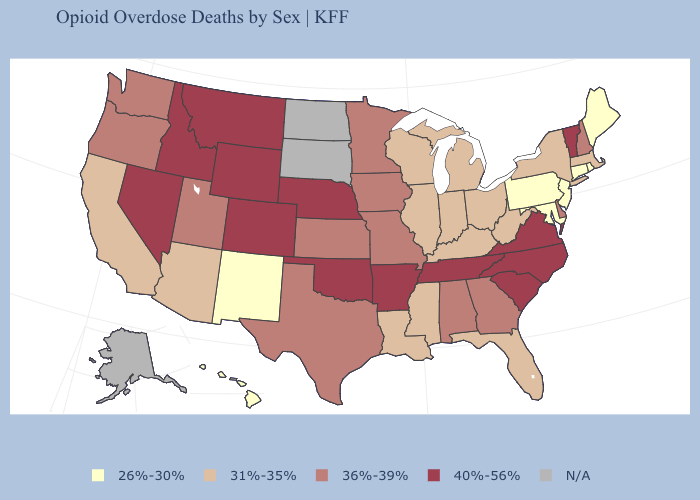Among the states that border South Dakota , which have the lowest value?
Write a very short answer. Iowa, Minnesota. Name the states that have a value in the range N/A?
Concise answer only. Alaska, North Dakota, South Dakota. Name the states that have a value in the range N/A?
Keep it brief. Alaska, North Dakota, South Dakota. What is the highest value in the USA?
Quick response, please. 40%-56%. Name the states that have a value in the range 36%-39%?
Be succinct. Alabama, Delaware, Georgia, Iowa, Kansas, Minnesota, Missouri, New Hampshire, Oregon, Texas, Utah, Washington. Does New Hampshire have the highest value in the USA?
Keep it brief. No. Does Oklahoma have the lowest value in the USA?
Concise answer only. No. What is the lowest value in the USA?
Keep it brief. 26%-30%. What is the highest value in the USA?
Be succinct. 40%-56%. What is the value of Connecticut?
Be succinct. 26%-30%. What is the value of West Virginia?
Keep it brief. 31%-35%. What is the value of Delaware?
Concise answer only. 36%-39%. Does Nebraska have the highest value in the MidWest?
Answer briefly. Yes. 